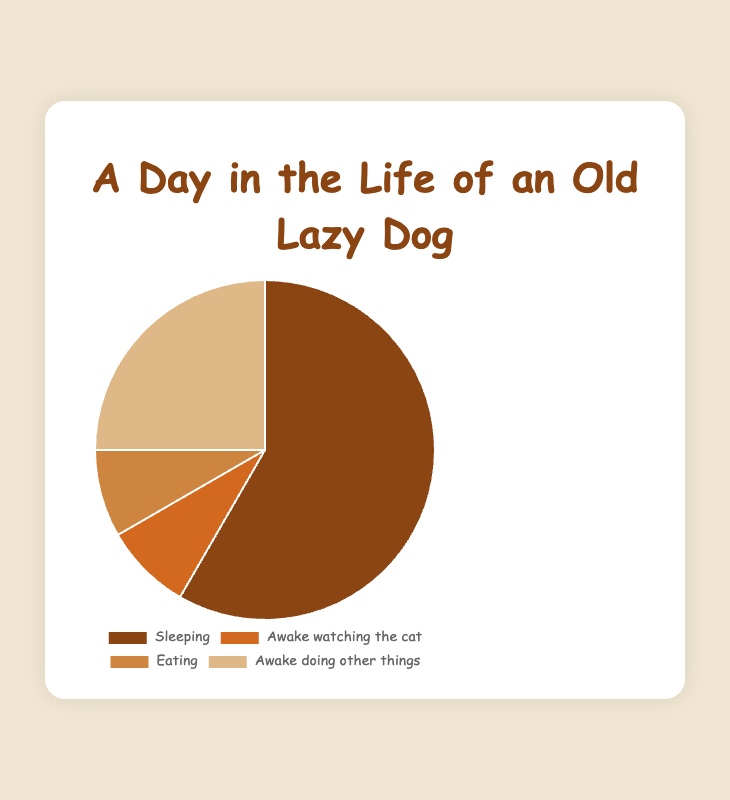What activity takes up the most time in the day? The pie chart shows the portions of different activities. The largest slice represents 14 hours dedicated to sleeping.
Answer: Sleeping Which two activities have the same amount of time spent? The pie chart indicates that both 'Awake watching the cat' and 'Eating' activities each take up 2 hours of the day.
Answer: Awake watching the cat and Eating How many more hours does the dog spend sleeping compared to watching the cat? The dog spends 14 hours sleeping and 2 hours watching the cat. The difference is 14 - 2 = 12 hours.
Answer: 12 hours What's the average time spent on activities other than sleeping? Total time on activities other than sleeping is 2 (watching the cat) + 2 (eating) + 6 (other things) = 10 hours. There are 3 activities, so the average is 10 / 3 ≈ 3.33 hours.
Answer: 3.33 hours Which activity uses the least amount of time? The pie chart shows that 'Awake watching the cat' and 'Eating' both use the smallest amount of time, which is 2 hours each.
Answer: Awake watching the cat and Eating What is the combined percentage of time spent awake doing other things and watching the cat? The dog spends 6 hours awake doing other things and 2 hours watching the cat. Total hours spent in a day is 24. So, the percentage is (6 + 2) / 24 * 100 = 33.33%.
Answer: 33.33% Compare the total hours spent being awake versus sleeping. The dog is awake for 2 (watching the cat) + 2 (eating) + 6 (other things) = 10 hours, and sleeps for 14 hours. 14 hours > 10 hours, so the dog spends more time sleeping.
Answer: More time sleeping What percentage of the day is spent eating? The dog spends 2 hours eating out of a total of 24 hours. The percentage is 2 / 24 * 100 = 8.33%.
Answer: 8.33% How does the size of the smallest activity's slice compare visually to the largest slice? Visually, the smallest slices ('Awake watching the cat' and 'Eating') take up 2 hours each. The largest slice (sleeping) takes up 14 hours. The largest slice appears significantly larger because it represents seven times the amount of time.
Answer: Significantly larger What's the total amount of time spent not sleeping? The total time not spent sleeping is 24 - 14 = 10 hours.
Answer: 10 hours 